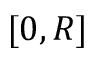Convert formula to latex. <formula><loc_0><loc_0><loc_500><loc_500>[ 0 , R ]</formula> 